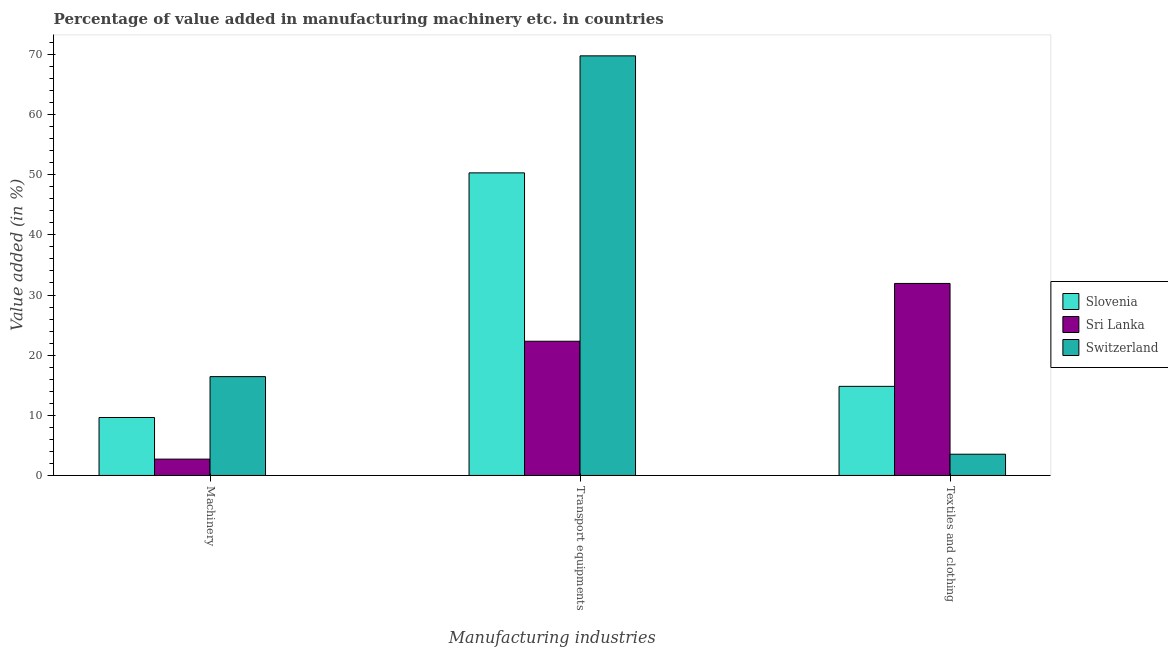How many different coloured bars are there?
Provide a short and direct response. 3. How many bars are there on the 2nd tick from the left?
Provide a succinct answer. 3. How many bars are there on the 2nd tick from the right?
Provide a succinct answer. 3. What is the label of the 3rd group of bars from the left?
Keep it short and to the point. Textiles and clothing. What is the value added in manufacturing textile and clothing in Sri Lanka?
Your answer should be very brief. 31.93. Across all countries, what is the maximum value added in manufacturing textile and clothing?
Your answer should be compact. 31.93. Across all countries, what is the minimum value added in manufacturing textile and clothing?
Your response must be concise. 3.53. In which country was the value added in manufacturing machinery maximum?
Keep it short and to the point. Switzerland. In which country was the value added in manufacturing machinery minimum?
Your answer should be compact. Sri Lanka. What is the total value added in manufacturing transport equipments in the graph?
Your answer should be very brief. 142.39. What is the difference between the value added in manufacturing textile and clothing in Switzerland and that in Slovenia?
Make the answer very short. -11.28. What is the difference between the value added in manufacturing machinery in Switzerland and the value added in manufacturing textile and clothing in Sri Lanka?
Give a very brief answer. -15.49. What is the average value added in manufacturing machinery per country?
Offer a very short reply. 9.59. What is the difference between the value added in manufacturing transport equipments and value added in manufacturing textile and clothing in Sri Lanka?
Offer a terse response. -9.61. What is the ratio of the value added in manufacturing textile and clothing in Switzerland to that in Slovenia?
Ensure brevity in your answer.  0.24. Is the value added in manufacturing textile and clothing in Switzerland less than that in Sri Lanka?
Provide a succinct answer. Yes. Is the difference between the value added in manufacturing textile and clothing in Sri Lanka and Switzerland greater than the difference between the value added in manufacturing transport equipments in Sri Lanka and Switzerland?
Your answer should be very brief. Yes. What is the difference between the highest and the second highest value added in manufacturing textile and clothing?
Ensure brevity in your answer.  17.11. What is the difference between the highest and the lowest value added in manufacturing textile and clothing?
Keep it short and to the point. 28.4. In how many countries, is the value added in manufacturing textile and clothing greater than the average value added in manufacturing textile and clothing taken over all countries?
Provide a succinct answer. 1. What does the 2nd bar from the left in Transport equipments represents?
Your response must be concise. Sri Lanka. What does the 3rd bar from the right in Transport equipments represents?
Ensure brevity in your answer.  Slovenia. Is it the case that in every country, the sum of the value added in manufacturing machinery and value added in manufacturing transport equipments is greater than the value added in manufacturing textile and clothing?
Your answer should be very brief. No. Are all the bars in the graph horizontal?
Provide a succinct answer. No. How many countries are there in the graph?
Ensure brevity in your answer.  3. What is the difference between two consecutive major ticks on the Y-axis?
Give a very brief answer. 10. Are the values on the major ticks of Y-axis written in scientific E-notation?
Offer a terse response. No. Does the graph contain any zero values?
Offer a terse response. No. Does the graph contain grids?
Your response must be concise. No. Where does the legend appear in the graph?
Ensure brevity in your answer.  Center right. How are the legend labels stacked?
Offer a very short reply. Vertical. What is the title of the graph?
Your answer should be compact. Percentage of value added in manufacturing machinery etc. in countries. Does "Nepal" appear as one of the legend labels in the graph?
Offer a very short reply. No. What is the label or title of the X-axis?
Make the answer very short. Manufacturing industries. What is the label or title of the Y-axis?
Offer a very short reply. Value added (in %). What is the Value added (in %) of Slovenia in Machinery?
Provide a short and direct response. 9.64. What is the Value added (in %) of Sri Lanka in Machinery?
Your answer should be compact. 2.72. What is the Value added (in %) in Switzerland in Machinery?
Make the answer very short. 16.43. What is the Value added (in %) in Slovenia in Transport equipments?
Keep it short and to the point. 50.31. What is the Value added (in %) in Sri Lanka in Transport equipments?
Keep it short and to the point. 22.32. What is the Value added (in %) of Switzerland in Transport equipments?
Provide a short and direct response. 69.77. What is the Value added (in %) of Slovenia in Textiles and clothing?
Provide a short and direct response. 14.81. What is the Value added (in %) of Sri Lanka in Textiles and clothing?
Offer a terse response. 31.93. What is the Value added (in %) in Switzerland in Textiles and clothing?
Make the answer very short. 3.53. Across all Manufacturing industries, what is the maximum Value added (in %) in Slovenia?
Provide a short and direct response. 50.31. Across all Manufacturing industries, what is the maximum Value added (in %) in Sri Lanka?
Give a very brief answer. 31.93. Across all Manufacturing industries, what is the maximum Value added (in %) in Switzerland?
Provide a short and direct response. 69.77. Across all Manufacturing industries, what is the minimum Value added (in %) of Slovenia?
Ensure brevity in your answer.  9.64. Across all Manufacturing industries, what is the minimum Value added (in %) in Sri Lanka?
Offer a very short reply. 2.72. Across all Manufacturing industries, what is the minimum Value added (in %) in Switzerland?
Ensure brevity in your answer.  3.53. What is the total Value added (in %) of Slovenia in the graph?
Make the answer very short. 74.76. What is the total Value added (in %) of Sri Lanka in the graph?
Provide a short and direct response. 56.96. What is the total Value added (in %) of Switzerland in the graph?
Your answer should be compact. 89.73. What is the difference between the Value added (in %) of Slovenia in Machinery and that in Transport equipments?
Keep it short and to the point. -40.67. What is the difference between the Value added (in %) of Sri Lanka in Machinery and that in Transport equipments?
Make the answer very short. -19.6. What is the difference between the Value added (in %) of Switzerland in Machinery and that in Transport equipments?
Your answer should be very brief. -53.34. What is the difference between the Value added (in %) in Slovenia in Machinery and that in Textiles and clothing?
Make the answer very short. -5.18. What is the difference between the Value added (in %) of Sri Lanka in Machinery and that in Textiles and clothing?
Your answer should be compact. -29.21. What is the difference between the Value added (in %) of Switzerland in Machinery and that in Textiles and clothing?
Make the answer very short. 12.9. What is the difference between the Value added (in %) of Slovenia in Transport equipments and that in Textiles and clothing?
Give a very brief answer. 35.5. What is the difference between the Value added (in %) of Sri Lanka in Transport equipments and that in Textiles and clothing?
Your answer should be compact. -9.61. What is the difference between the Value added (in %) of Switzerland in Transport equipments and that in Textiles and clothing?
Provide a short and direct response. 66.24. What is the difference between the Value added (in %) in Slovenia in Machinery and the Value added (in %) in Sri Lanka in Transport equipments?
Offer a very short reply. -12.68. What is the difference between the Value added (in %) in Slovenia in Machinery and the Value added (in %) in Switzerland in Transport equipments?
Your answer should be compact. -60.13. What is the difference between the Value added (in %) of Sri Lanka in Machinery and the Value added (in %) of Switzerland in Transport equipments?
Provide a short and direct response. -67.05. What is the difference between the Value added (in %) of Slovenia in Machinery and the Value added (in %) of Sri Lanka in Textiles and clothing?
Provide a succinct answer. -22.29. What is the difference between the Value added (in %) in Slovenia in Machinery and the Value added (in %) in Switzerland in Textiles and clothing?
Offer a terse response. 6.11. What is the difference between the Value added (in %) in Sri Lanka in Machinery and the Value added (in %) in Switzerland in Textiles and clothing?
Offer a terse response. -0.81. What is the difference between the Value added (in %) of Slovenia in Transport equipments and the Value added (in %) of Sri Lanka in Textiles and clothing?
Give a very brief answer. 18.38. What is the difference between the Value added (in %) of Slovenia in Transport equipments and the Value added (in %) of Switzerland in Textiles and clothing?
Make the answer very short. 46.78. What is the difference between the Value added (in %) of Sri Lanka in Transport equipments and the Value added (in %) of Switzerland in Textiles and clothing?
Offer a terse response. 18.78. What is the average Value added (in %) of Slovenia per Manufacturing industries?
Ensure brevity in your answer.  24.92. What is the average Value added (in %) of Sri Lanka per Manufacturing industries?
Give a very brief answer. 18.99. What is the average Value added (in %) of Switzerland per Manufacturing industries?
Provide a succinct answer. 29.91. What is the difference between the Value added (in %) of Slovenia and Value added (in %) of Sri Lanka in Machinery?
Make the answer very short. 6.92. What is the difference between the Value added (in %) in Slovenia and Value added (in %) in Switzerland in Machinery?
Give a very brief answer. -6.8. What is the difference between the Value added (in %) of Sri Lanka and Value added (in %) of Switzerland in Machinery?
Your response must be concise. -13.72. What is the difference between the Value added (in %) in Slovenia and Value added (in %) in Sri Lanka in Transport equipments?
Your response must be concise. 28. What is the difference between the Value added (in %) of Slovenia and Value added (in %) of Switzerland in Transport equipments?
Your answer should be compact. -19.46. What is the difference between the Value added (in %) in Sri Lanka and Value added (in %) in Switzerland in Transport equipments?
Your answer should be very brief. -47.45. What is the difference between the Value added (in %) of Slovenia and Value added (in %) of Sri Lanka in Textiles and clothing?
Offer a terse response. -17.11. What is the difference between the Value added (in %) of Slovenia and Value added (in %) of Switzerland in Textiles and clothing?
Ensure brevity in your answer.  11.28. What is the difference between the Value added (in %) of Sri Lanka and Value added (in %) of Switzerland in Textiles and clothing?
Your response must be concise. 28.4. What is the ratio of the Value added (in %) of Slovenia in Machinery to that in Transport equipments?
Your response must be concise. 0.19. What is the ratio of the Value added (in %) in Sri Lanka in Machinery to that in Transport equipments?
Make the answer very short. 0.12. What is the ratio of the Value added (in %) in Switzerland in Machinery to that in Transport equipments?
Give a very brief answer. 0.24. What is the ratio of the Value added (in %) in Slovenia in Machinery to that in Textiles and clothing?
Ensure brevity in your answer.  0.65. What is the ratio of the Value added (in %) in Sri Lanka in Machinery to that in Textiles and clothing?
Provide a succinct answer. 0.09. What is the ratio of the Value added (in %) of Switzerland in Machinery to that in Textiles and clothing?
Keep it short and to the point. 4.65. What is the ratio of the Value added (in %) of Slovenia in Transport equipments to that in Textiles and clothing?
Your answer should be very brief. 3.4. What is the ratio of the Value added (in %) of Sri Lanka in Transport equipments to that in Textiles and clothing?
Give a very brief answer. 0.7. What is the ratio of the Value added (in %) of Switzerland in Transport equipments to that in Textiles and clothing?
Offer a very short reply. 19.76. What is the difference between the highest and the second highest Value added (in %) in Slovenia?
Keep it short and to the point. 35.5. What is the difference between the highest and the second highest Value added (in %) in Sri Lanka?
Keep it short and to the point. 9.61. What is the difference between the highest and the second highest Value added (in %) in Switzerland?
Provide a succinct answer. 53.34. What is the difference between the highest and the lowest Value added (in %) of Slovenia?
Offer a terse response. 40.67. What is the difference between the highest and the lowest Value added (in %) in Sri Lanka?
Make the answer very short. 29.21. What is the difference between the highest and the lowest Value added (in %) of Switzerland?
Your answer should be compact. 66.24. 